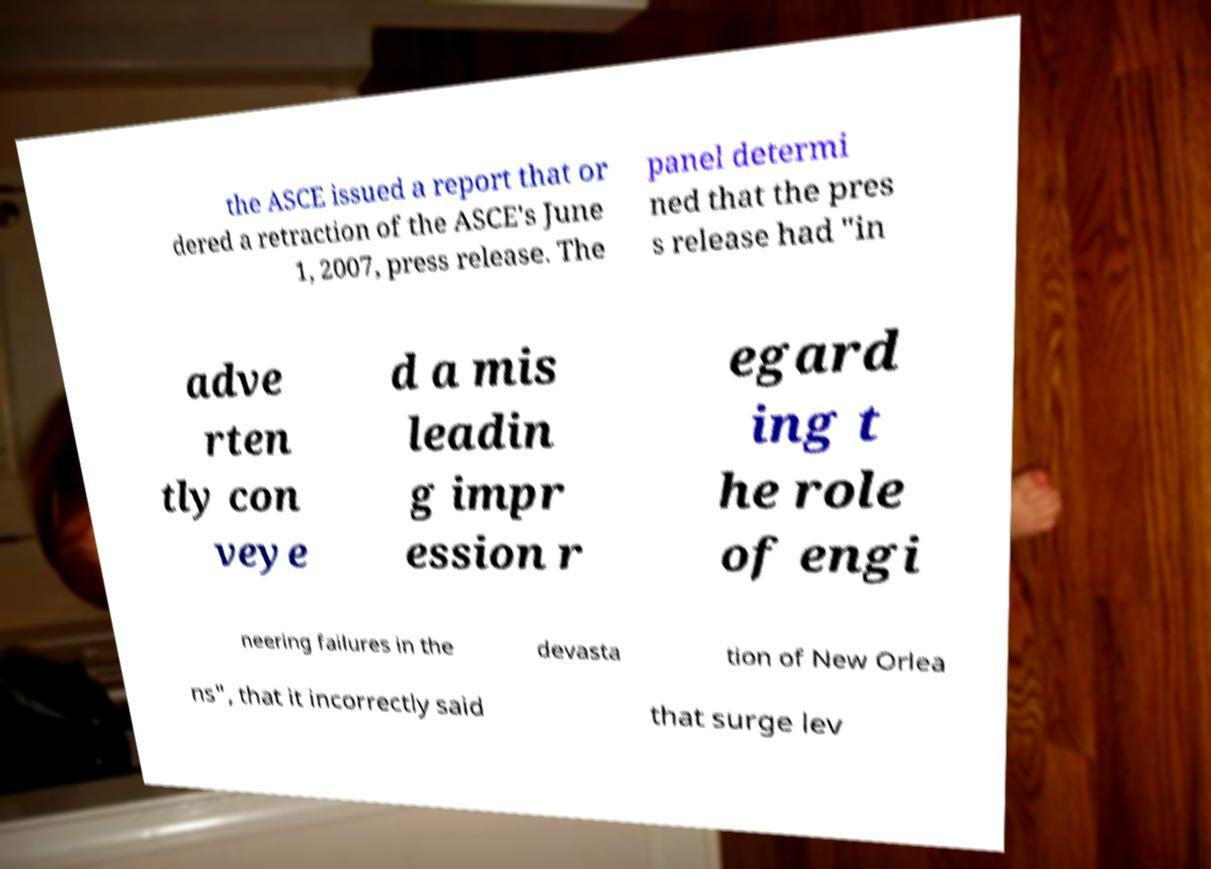Please read and relay the text visible in this image. What does it say? the ASCE issued a report that or dered a retraction of the ASCE's June 1, 2007, press release. The panel determi ned that the pres s release had "in adve rten tly con veye d a mis leadin g impr ession r egard ing t he role of engi neering failures in the devasta tion of New Orlea ns", that it incorrectly said that surge lev 